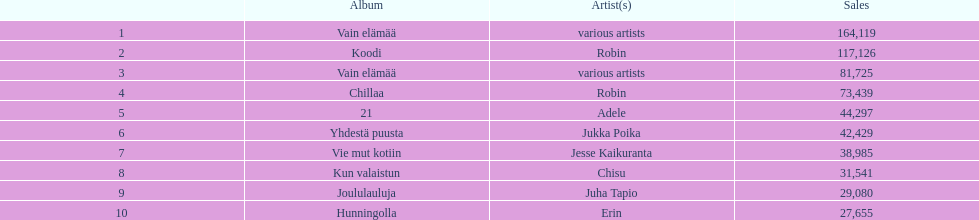Tell me what album had the most sold. Vain elämää. 